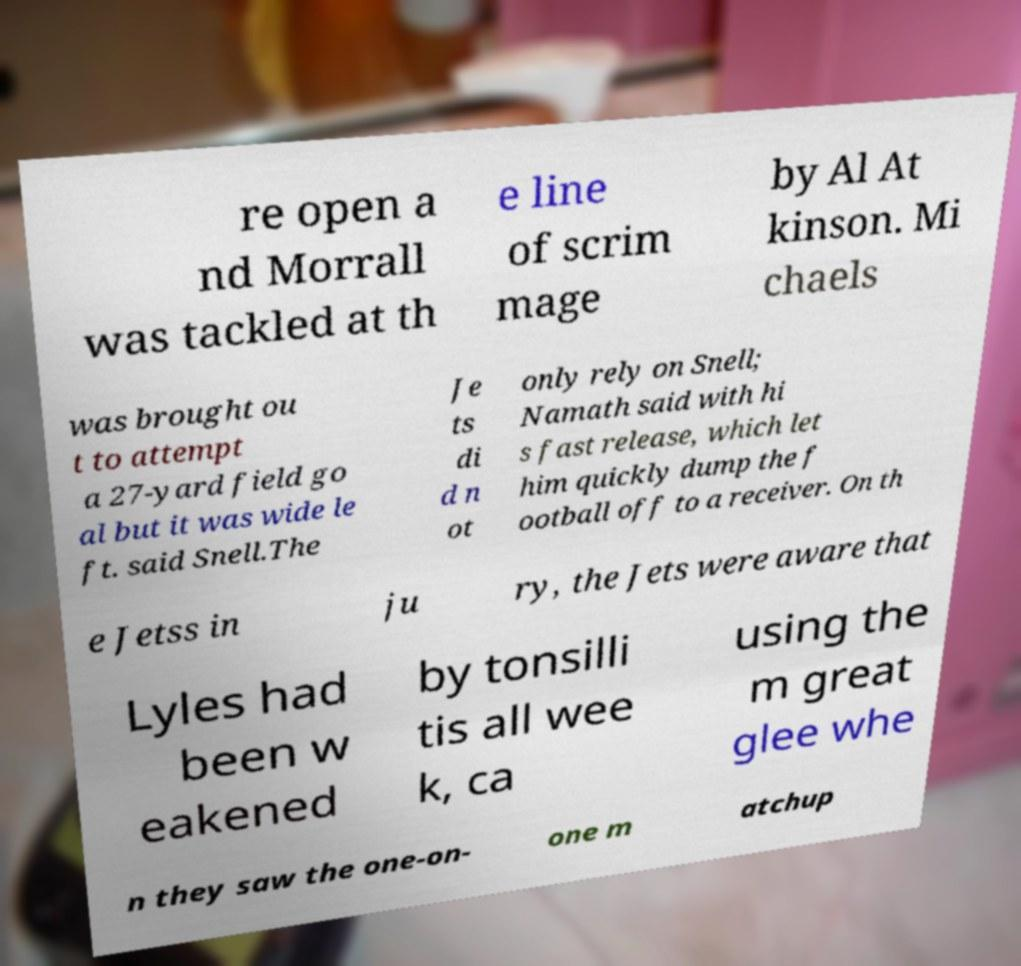Could you extract and type out the text from this image? re open a nd Morrall was tackled at th e line of scrim mage by Al At kinson. Mi chaels was brought ou t to attempt a 27-yard field go al but it was wide le ft. said Snell.The Je ts di d n ot only rely on Snell; Namath said with hi s fast release, which let him quickly dump the f ootball off to a receiver. On th e Jetss in ju ry, the Jets were aware that Lyles had been w eakened by tonsilli tis all wee k, ca using the m great glee whe n they saw the one-on- one m atchup 